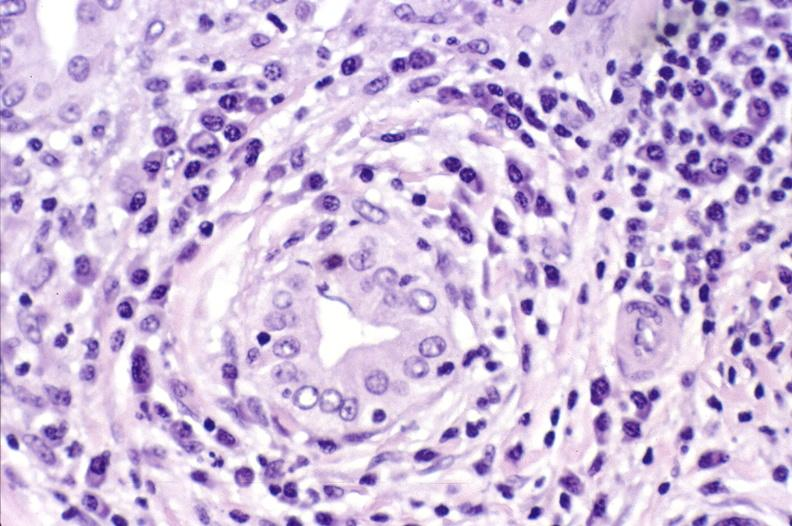what is present?
Answer the question using a single word or phrase. Hepatobiliary 